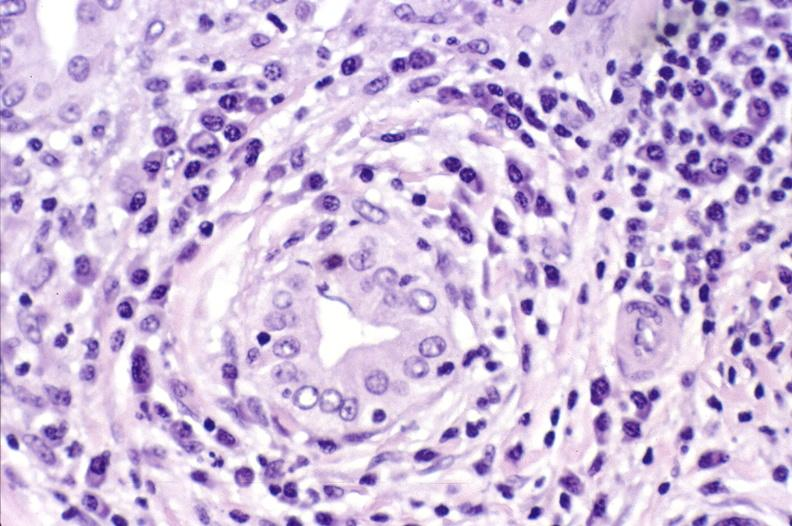what is present?
Answer the question using a single word or phrase. Hepatobiliary 